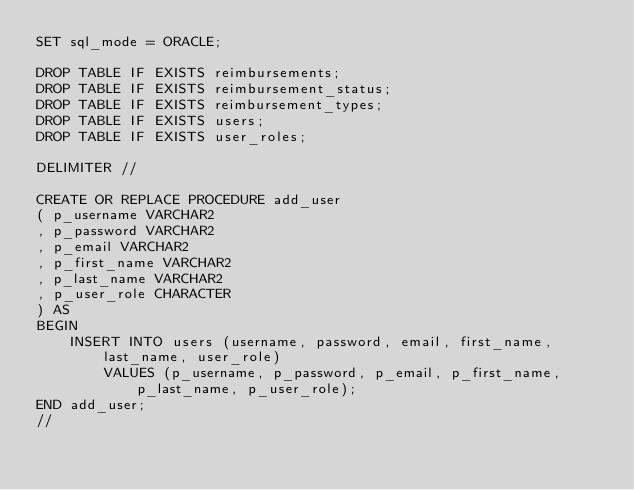<code> <loc_0><loc_0><loc_500><loc_500><_SQL_>SET sql_mode = ORACLE;

DROP TABLE IF EXISTS reimbursements;
DROP TABLE IF EXISTS reimbursement_status;
DROP TABLE IF EXISTS reimbursement_types;
DROP TABLE IF EXISTS users;
DROP TABLE IF EXISTS user_roles;

DELIMITER //

CREATE OR REPLACE PROCEDURE add_user
( p_username VARCHAR2
, p_password VARCHAR2
, p_email VARCHAR2
, p_first_name VARCHAR2
, p_last_name VARCHAR2
, p_user_role CHARACTER
) AS
BEGIN
    INSERT INTO users (username, password, email, first_name, last_name, user_role)
        VALUES (p_username, p_password, p_email, p_first_name, p_last_name, p_user_role);
END add_user;
//
</code> 